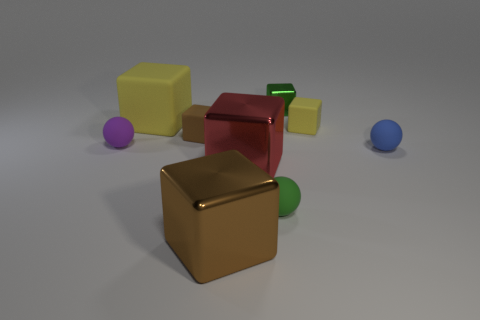What is the material of the green thing that is the same shape as the big brown thing?
Offer a very short reply. Metal. There is a tiny green block; are there any purple rubber balls in front of it?
Provide a short and direct response. Yes. Do the object that is right of the small yellow cube and the purple object have the same material?
Make the answer very short. Yes. Are there any other cubes of the same color as the large matte cube?
Your answer should be very brief. Yes. The brown matte thing has what shape?
Provide a short and direct response. Cube. There is a large block that is behind the sphere that is behind the small blue rubber thing; what is its color?
Provide a short and direct response. Yellow. There is a yellow matte cube on the right side of the green matte ball; what is its size?
Provide a short and direct response. Small. Is there a small thing made of the same material as the red block?
Provide a short and direct response. Yes. How many blue things are the same shape as the big red metal thing?
Offer a terse response. 0. The yellow matte object that is to the left of the yellow rubber thing that is to the right of the shiny thing on the left side of the red shiny cube is what shape?
Offer a terse response. Cube. 